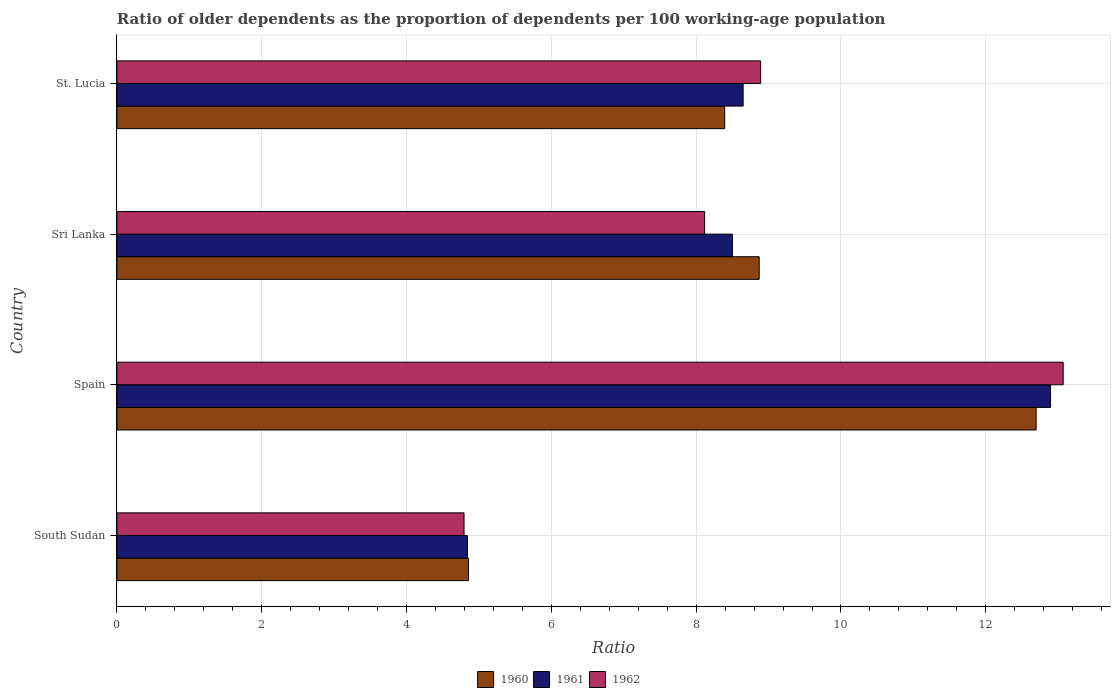How many bars are there on the 1st tick from the top?
Your response must be concise. 3. How many bars are there on the 2nd tick from the bottom?
Make the answer very short. 3. What is the label of the 4th group of bars from the top?
Provide a succinct answer. South Sudan. In how many cases, is the number of bars for a given country not equal to the number of legend labels?
Make the answer very short. 0. What is the age dependency ratio(old) in 1961 in Spain?
Keep it short and to the point. 12.89. Across all countries, what is the maximum age dependency ratio(old) in 1961?
Your answer should be very brief. 12.89. Across all countries, what is the minimum age dependency ratio(old) in 1961?
Your answer should be compact. 4.84. In which country was the age dependency ratio(old) in 1961 minimum?
Your response must be concise. South Sudan. What is the total age dependency ratio(old) in 1962 in the graph?
Ensure brevity in your answer.  34.87. What is the difference between the age dependency ratio(old) in 1961 in South Sudan and that in St. Lucia?
Provide a short and direct response. -3.81. What is the difference between the age dependency ratio(old) in 1961 in South Sudan and the age dependency ratio(old) in 1962 in St. Lucia?
Give a very brief answer. -4.05. What is the average age dependency ratio(old) in 1961 per country?
Provide a short and direct response. 8.72. What is the difference between the age dependency ratio(old) in 1960 and age dependency ratio(old) in 1962 in St. Lucia?
Offer a terse response. -0.5. In how many countries, is the age dependency ratio(old) in 1960 greater than 12 ?
Your answer should be very brief. 1. What is the ratio of the age dependency ratio(old) in 1960 in South Sudan to that in Spain?
Your response must be concise. 0.38. Is the difference between the age dependency ratio(old) in 1960 in Spain and St. Lucia greater than the difference between the age dependency ratio(old) in 1962 in Spain and St. Lucia?
Offer a very short reply. Yes. What is the difference between the highest and the second highest age dependency ratio(old) in 1960?
Your answer should be compact. 3.82. What is the difference between the highest and the lowest age dependency ratio(old) in 1960?
Offer a terse response. 7.84. What does the 1st bar from the top in Sri Lanka represents?
Offer a terse response. 1962. How many countries are there in the graph?
Offer a very short reply. 4. Are the values on the major ticks of X-axis written in scientific E-notation?
Make the answer very short. No. Does the graph contain any zero values?
Your response must be concise. No. Does the graph contain grids?
Give a very brief answer. Yes. How many legend labels are there?
Provide a succinct answer. 3. What is the title of the graph?
Make the answer very short. Ratio of older dependents as the proportion of dependents per 100 working-age population. What is the label or title of the X-axis?
Offer a very short reply. Ratio. What is the Ratio in 1960 in South Sudan?
Your answer should be very brief. 4.86. What is the Ratio in 1961 in South Sudan?
Ensure brevity in your answer.  4.84. What is the Ratio of 1962 in South Sudan?
Give a very brief answer. 4.79. What is the Ratio of 1960 in Spain?
Offer a terse response. 12.7. What is the Ratio of 1961 in Spain?
Provide a succinct answer. 12.89. What is the Ratio of 1962 in Spain?
Your response must be concise. 13.07. What is the Ratio of 1960 in Sri Lanka?
Make the answer very short. 8.87. What is the Ratio in 1961 in Sri Lanka?
Give a very brief answer. 8.5. What is the Ratio of 1962 in Sri Lanka?
Offer a very short reply. 8.12. What is the Ratio in 1960 in St. Lucia?
Your answer should be very brief. 8.39. What is the Ratio in 1961 in St. Lucia?
Offer a terse response. 8.65. What is the Ratio of 1962 in St. Lucia?
Offer a very short reply. 8.89. Across all countries, what is the maximum Ratio of 1960?
Your response must be concise. 12.7. Across all countries, what is the maximum Ratio in 1961?
Your answer should be very brief. 12.89. Across all countries, what is the maximum Ratio in 1962?
Provide a succinct answer. 13.07. Across all countries, what is the minimum Ratio of 1960?
Provide a succinct answer. 4.86. Across all countries, what is the minimum Ratio of 1961?
Your response must be concise. 4.84. Across all countries, what is the minimum Ratio of 1962?
Provide a succinct answer. 4.79. What is the total Ratio in 1960 in the graph?
Keep it short and to the point. 34.82. What is the total Ratio in 1961 in the graph?
Your response must be concise. 34.88. What is the total Ratio of 1962 in the graph?
Your answer should be very brief. 34.87. What is the difference between the Ratio of 1960 in South Sudan and that in Spain?
Offer a terse response. -7.84. What is the difference between the Ratio in 1961 in South Sudan and that in Spain?
Provide a succinct answer. -8.05. What is the difference between the Ratio in 1962 in South Sudan and that in Spain?
Your answer should be very brief. -8.27. What is the difference between the Ratio in 1960 in South Sudan and that in Sri Lanka?
Your answer should be very brief. -4.01. What is the difference between the Ratio of 1961 in South Sudan and that in Sri Lanka?
Offer a very short reply. -3.66. What is the difference between the Ratio of 1962 in South Sudan and that in Sri Lanka?
Offer a terse response. -3.32. What is the difference between the Ratio in 1960 in South Sudan and that in St. Lucia?
Provide a succinct answer. -3.54. What is the difference between the Ratio of 1961 in South Sudan and that in St. Lucia?
Keep it short and to the point. -3.81. What is the difference between the Ratio of 1962 in South Sudan and that in St. Lucia?
Provide a succinct answer. -4.1. What is the difference between the Ratio in 1960 in Spain and that in Sri Lanka?
Ensure brevity in your answer.  3.82. What is the difference between the Ratio in 1961 in Spain and that in Sri Lanka?
Offer a terse response. 4.39. What is the difference between the Ratio in 1962 in Spain and that in Sri Lanka?
Your answer should be very brief. 4.95. What is the difference between the Ratio in 1960 in Spain and that in St. Lucia?
Offer a very short reply. 4.3. What is the difference between the Ratio in 1961 in Spain and that in St. Lucia?
Provide a succinct answer. 4.25. What is the difference between the Ratio of 1962 in Spain and that in St. Lucia?
Offer a very short reply. 4.18. What is the difference between the Ratio of 1960 in Sri Lanka and that in St. Lucia?
Your response must be concise. 0.48. What is the difference between the Ratio of 1961 in Sri Lanka and that in St. Lucia?
Offer a terse response. -0.15. What is the difference between the Ratio in 1962 in Sri Lanka and that in St. Lucia?
Offer a terse response. -0.77. What is the difference between the Ratio in 1960 in South Sudan and the Ratio in 1961 in Spain?
Make the answer very short. -8.04. What is the difference between the Ratio in 1960 in South Sudan and the Ratio in 1962 in Spain?
Ensure brevity in your answer.  -8.21. What is the difference between the Ratio in 1961 in South Sudan and the Ratio in 1962 in Spain?
Offer a terse response. -8.23. What is the difference between the Ratio of 1960 in South Sudan and the Ratio of 1961 in Sri Lanka?
Ensure brevity in your answer.  -3.64. What is the difference between the Ratio of 1960 in South Sudan and the Ratio of 1962 in Sri Lanka?
Your answer should be compact. -3.26. What is the difference between the Ratio in 1961 in South Sudan and the Ratio in 1962 in Sri Lanka?
Ensure brevity in your answer.  -3.28. What is the difference between the Ratio of 1960 in South Sudan and the Ratio of 1961 in St. Lucia?
Keep it short and to the point. -3.79. What is the difference between the Ratio in 1960 in South Sudan and the Ratio in 1962 in St. Lucia?
Offer a very short reply. -4.03. What is the difference between the Ratio of 1961 in South Sudan and the Ratio of 1962 in St. Lucia?
Offer a very short reply. -4.05. What is the difference between the Ratio in 1960 in Spain and the Ratio in 1961 in Sri Lanka?
Keep it short and to the point. 4.19. What is the difference between the Ratio of 1960 in Spain and the Ratio of 1962 in Sri Lanka?
Ensure brevity in your answer.  4.58. What is the difference between the Ratio in 1961 in Spain and the Ratio in 1962 in Sri Lanka?
Keep it short and to the point. 4.78. What is the difference between the Ratio of 1960 in Spain and the Ratio of 1961 in St. Lucia?
Make the answer very short. 4.05. What is the difference between the Ratio of 1960 in Spain and the Ratio of 1962 in St. Lucia?
Offer a terse response. 3.8. What is the difference between the Ratio of 1961 in Spain and the Ratio of 1962 in St. Lucia?
Make the answer very short. 4. What is the difference between the Ratio of 1960 in Sri Lanka and the Ratio of 1961 in St. Lucia?
Give a very brief answer. 0.22. What is the difference between the Ratio in 1960 in Sri Lanka and the Ratio in 1962 in St. Lucia?
Make the answer very short. -0.02. What is the difference between the Ratio in 1961 in Sri Lanka and the Ratio in 1962 in St. Lucia?
Your response must be concise. -0.39. What is the average Ratio in 1960 per country?
Your response must be concise. 8.7. What is the average Ratio in 1961 per country?
Your answer should be very brief. 8.72. What is the average Ratio in 1962 per country?
Your answer should be compact. 8.72. What is the difference between the Ratio in 1960 and Ratio in 1961 in South Sudan?
Make the answer very short. 0.01. What is the difference between the Ratio in 1960 and Ratio in 1962 in South Sudan?
Offer a very short reply. 0.06. What is the difference between the Ratio of 1961 and Ratio of 1962 in South Sudan?
Your response must be concise. 0.05. What is the difference between the Ratio of 1960 and Ratio of 1961 in Spain?
Ensure brevity in your answer.  -0.2. What is the difference between the Ratio of 1960 and Ratio of 1962 in Spain?
Provide a short and direct response. -0.37. What is the difference between the Ratio of 1961 and Ratio of 1962 in Spain?
Provide a succinct answer. -0.17. What is the difference between the Ratio of 1960 and Ratio of 1961 in Sri Lanka?
Provide a succinct answer. 0.37. What is the difference between the Ratio in 1960 and Ratio in 1962 in Sri Lanka?
Give a very brief answer. 0.75. What is the difference between the Ratio in 1961 and Ratio in 1962 in Sri Lanka?
Give a very brief answer. 0.38. What is the difference between the Ratio in 1960 and Ratio in 1961 in St. Lucia?
Offer a terse response. -0.26. What is the difference between the Ratio in 1960 and Ratio in 1962 in St. Lucia?
Offer a terse response. -0.5. What is the difference between the Ratio of 1961 and Ratio of 1962 in St. Lucia?
Offer a very short reply. -0.24. What is the ratio of the Ratio of 1960 in South Sudan to that in Spain?
Your answer should be very brief. 0.38. What is the ratio of the Ratio in 1961 in South Sudan to that in Spain?
Your answer should be compact. 0.38. What is the ratio of the Ratio of 1962 in South Sudan to that in Spain?
Your response must be concise. 0.37. What is the ratio of the Ratio of 1960 in South Sudan to that in Sri Lanka?
Make the answer very short. 0.55. What is the ratio of the Ratio in 1961 in South Sudan to that in Sri Lanka?
Provide a short and direct response. 0.57. What is the ratio of the Ratio of 1962 in South Sudan to that in Sri Lanka?
Keep it short and to the point. 0.59. What is the ratio of the Ratio in 1960 in South Sudan to that in St. Lucia?
Give a very brief answer. 0.58. What is the ratio of the Ratio in 1961 in South Sudan to that in St. Lucia?
Ensure brevity in your answer.  0.56. What is the ratio of the Ratio of 1962 in South Sudan to that in St. Lucia?
Give a very brief answer. 0.54. What is the ratio of the Ratio in 1960 in Spain to that in Sri Lanka?
Your response must be concise. 1.43. What is the ratio of the Ratio of 1961 in Spain to that in Sri Lanka?
Your response must be concise. 1.52. What is the ratio of the Ratio of 1962 in Spain to that in Sri Lanka?
Ensure brevity in your answer.  1.61. What is the ratio of the Ratio in 1960 in Spain to that in St. Lucia?
Offer a very short reply. 1.51. What is the ratio of the Ratio in 1961 in Spain to that in St. Lucia?
Your answer should be compact. 1.49. What is the ratio of the Ratio in 1962 in Spain to that in St. Lucia?
Offer a terse response. 1.47. What is the ratio of the Ratio in 1960 in Sri Lanka to that in St. Lucia?
Your response must be concise. 1.06. What is the ratio of the Ratio in 1961 in Sri Lanka to that in St. Lucia?
Provide a short and direct response. 0.98. What is the ratio of the Ratio of 1962 in Sri Lanka to that in St. Lucia?
Your response must be concise. 0.91. What is the difference between the highest and the second highest Ratio in 1960?
Your response must be concise. 3.82. What is the difference between the highest and the second highest Ratio of 1961?
Offer a terse response. 4.25. What is the difference between the highest and the second highest Ratio of 1962?
Offer a very short reply. 4.18. What is the difference between the highest and the lowest Ratio in 1960?
Offer a very short reply. 7.84. What is the difference between the highest and the lowest Ratio of 1961?
Give a very brief answer. 8.05. What is the difference between the highest and the lowest Ratio of 1962?
Provide a short and direct response. 8.27. 